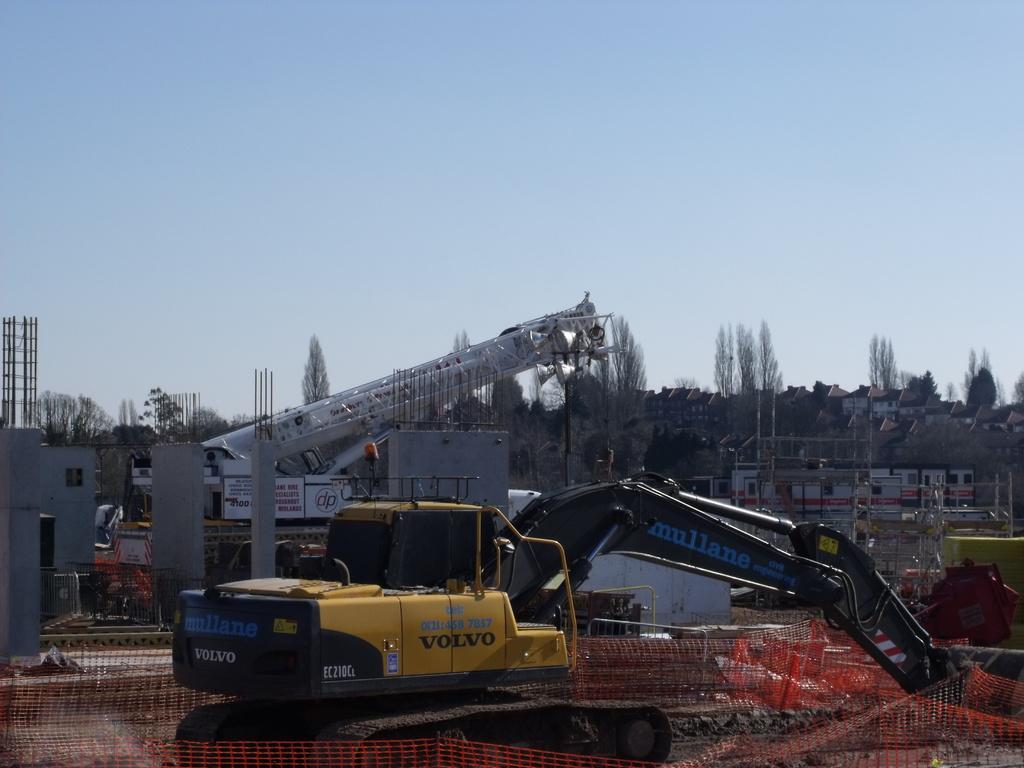How would you summarize this image in a sentence or two? In this image we can see many buildings and houses in the background. We can see a construction site in the left most of the image. There is a vehicle at the center of the image. 